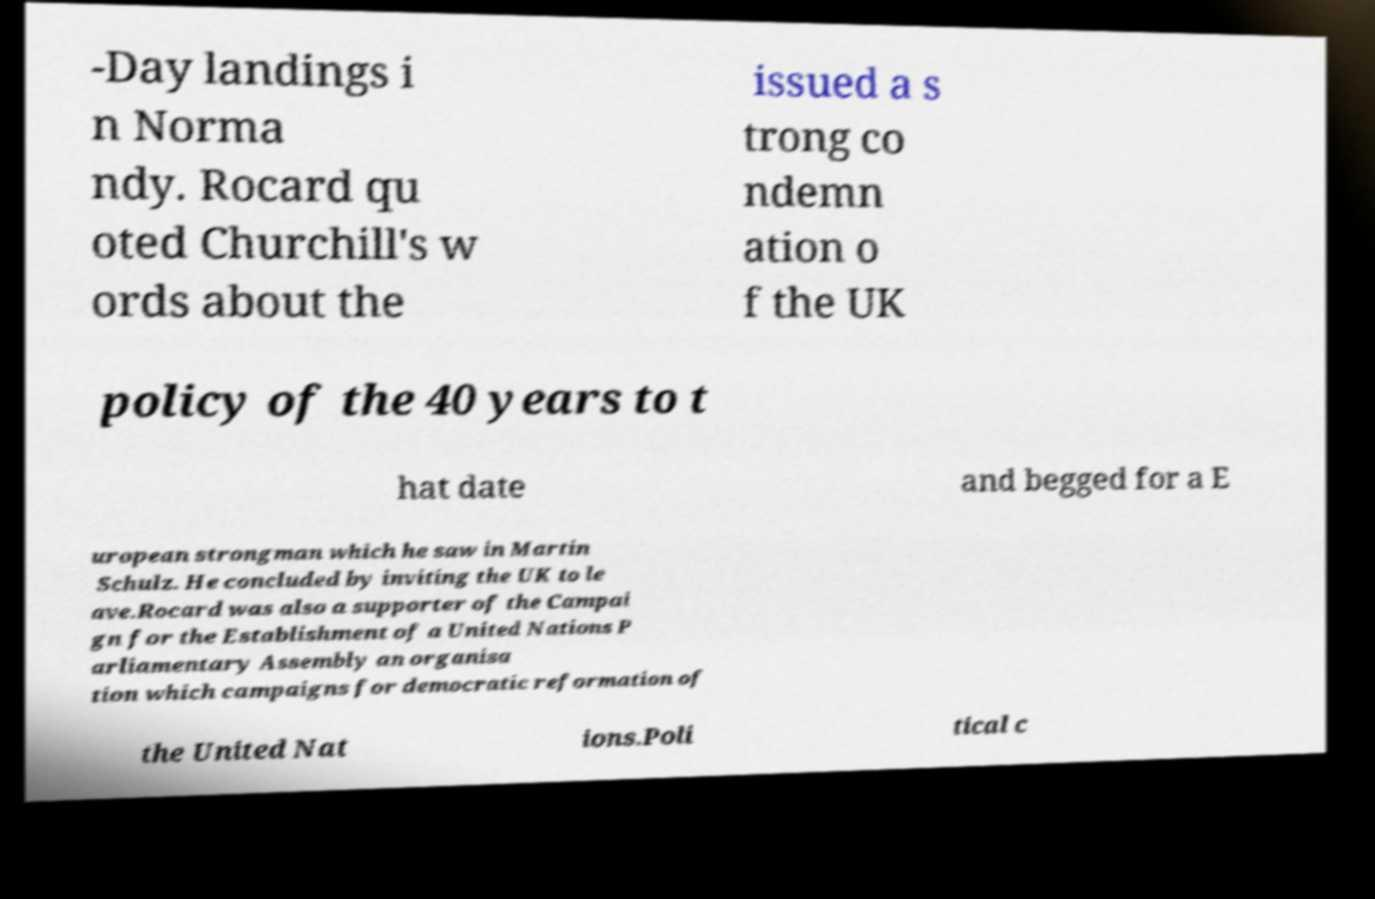Can you read and provide the text displayed in the image?This photo seems to have some interesting text. Can you extract and type it out for me? -Day landings i n Norma ndy. Rocard qu oted Churchill's w ords about the issued a s trong co ndemn ation o f the UK policy of the 40 years to t hat date and begged for a E uropean strongman which he saw in Martin Schulz. He concluded by inviting the UK to le ave.Rocard was also a supporter of the Campai gn for the Establishment of a United Nations P arliamentary Assembly an organisa tion which campaigns for democratic reformation of the United Nat ions.Poli tical c 